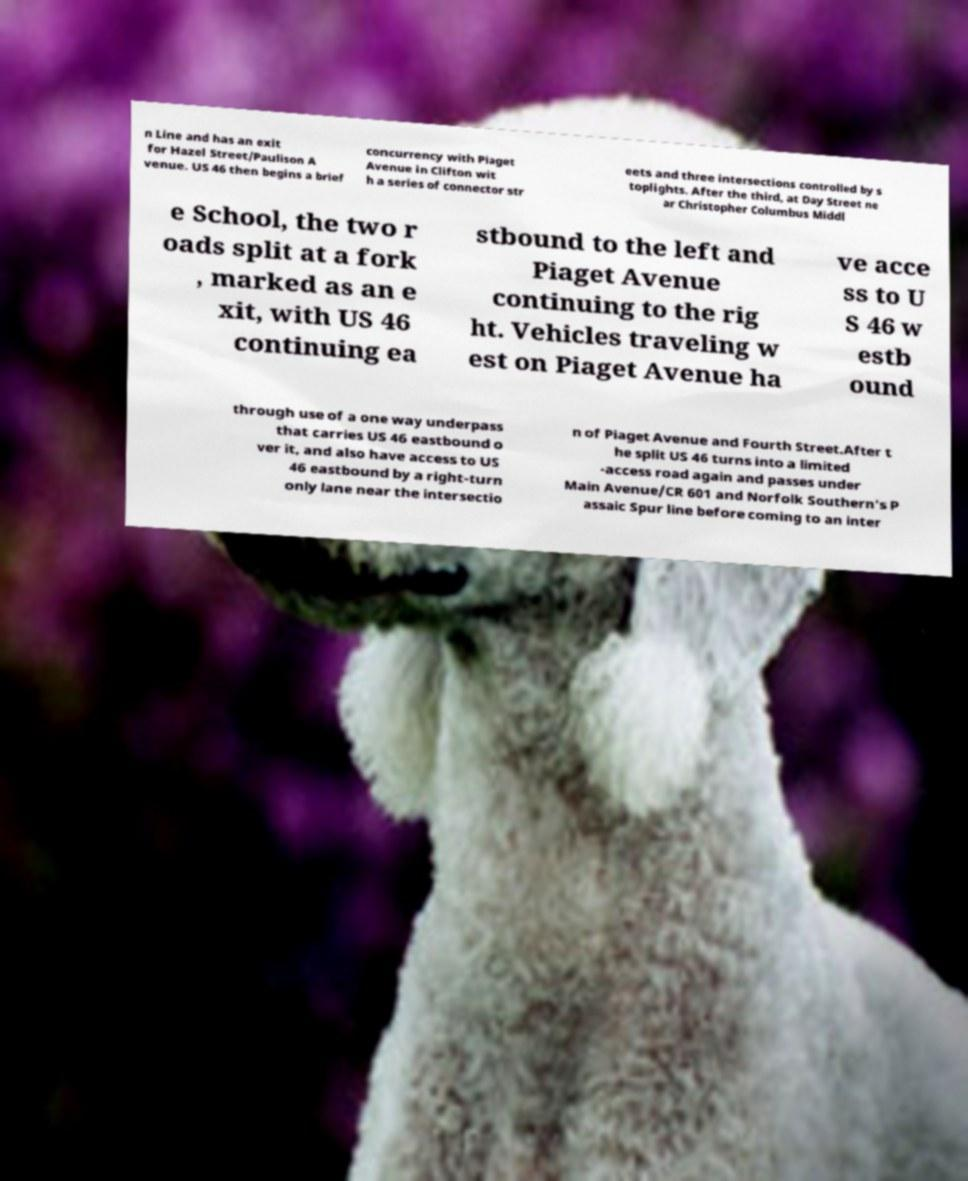Please read and relay the text visible in this image. What does it say? n Line and has an exit for Hazel Street/Paulison A venue. US 46 then begins a brief concurrency with Piaget Avenue in Clifton wit h a series of connector str eets and three intersections controlled by s toplights. After the third, at Day Street ne ar Christopher Columbus Middl e School, the two r oads split at a fork , marked as an e xit, with US 46 continuing ea stbound to the left and Piaget Avenue continuing to the rig ht. Vehicles traveling w est on Piaget Avenue ha ve acce ss to U S 46 w estb ound through use of a one way underpass that carries US 46 eastbound o ver it, and also have access to US 46 eastbound by a right-turn only lane near the intersectio n of Piaget Avenue and Fourth Street.After t he split US 46 turns into a limited -access road again and passes under Main Avenue/CR 601 and Norfolk Southern's P assaic Spur line before coming to an inter 